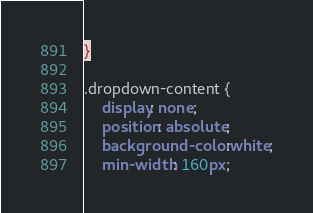<code> <loc_0><loc_0><loc_500><loc_500><_CSS_>}

.dropdown-content {
    display: none;
    position: absolute;
    background-color:white;
    min-width: 160px;</code> 